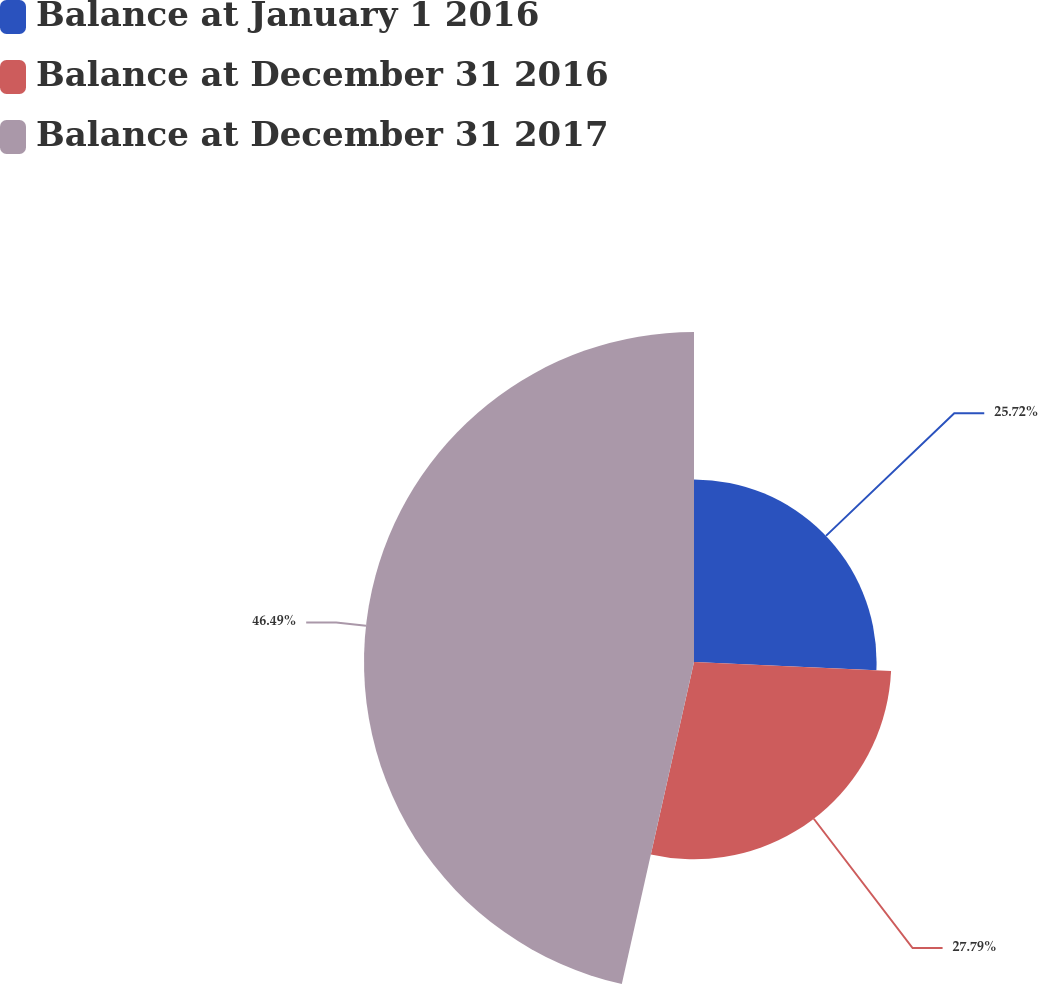Convert chart to OTSL. <chart><loc_0><loc_0><loc_500><loc_500><pie_chart><fcel>Balance at January 1 2016<fcel>Balance at December 31 2016<fcel>Balance at December 31 2017<nl><fcel>25.72%<fcel>27.79%<fcel>46.49%<nl></chart> 